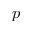Convert formula to latex. <formula><loc_0><loc_0><loc_500><loc_500>p</formula> 